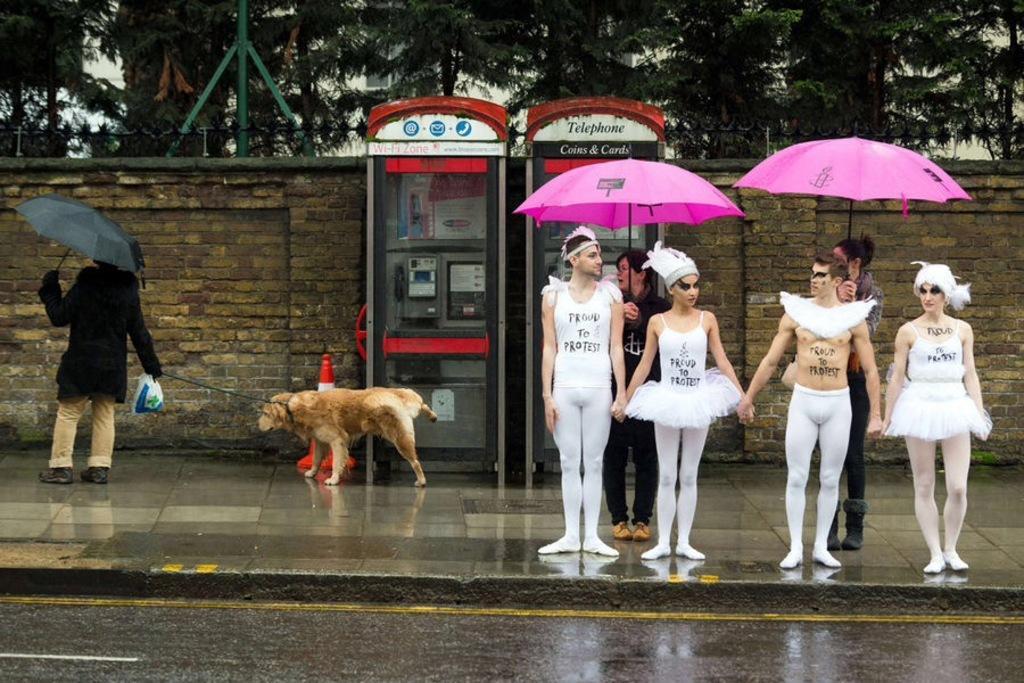Describe this image in one or two sentences. In the image I can see a place where we have two telephone booths and some people with different costume and behind them there are two other people holding the umbrellas and also I can see a dog and a traffic cone to the side. 